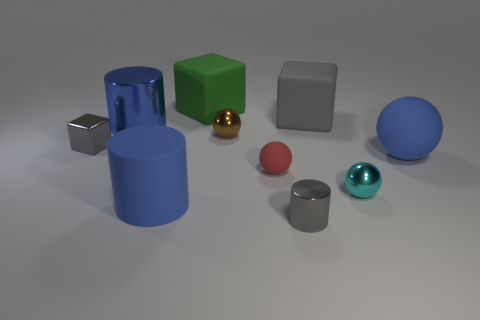Subtract 1 cylinders. How many cylinders are left? 2 Subtract all cyan spheres. How many spheres are left? 3 Subtract all tiny cyan metal spheres. How many spheres are left? 3 Subtract all gray balls. Subtract all purple cubes. How many balls are left? 4 Subtract all cylinders. How many objects are left? 7 Subtract all blue spheres. Subtract all tiny shiny objects. How many objects are left? 5 Add 7 tiny brown shiny spheres. How many tiny brown shiny spheres are left? 8 Add 6 gray matte cubes. How many gray matte cubes exist? 7 Subtract 1 gray cylinders. How many objects are left? 9 